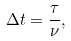Convert formula to latex. <formula><loc_0><loc_0><loc_500><loc_500>\Delta t = \frac { \tau } { \nu } ,</formula> 